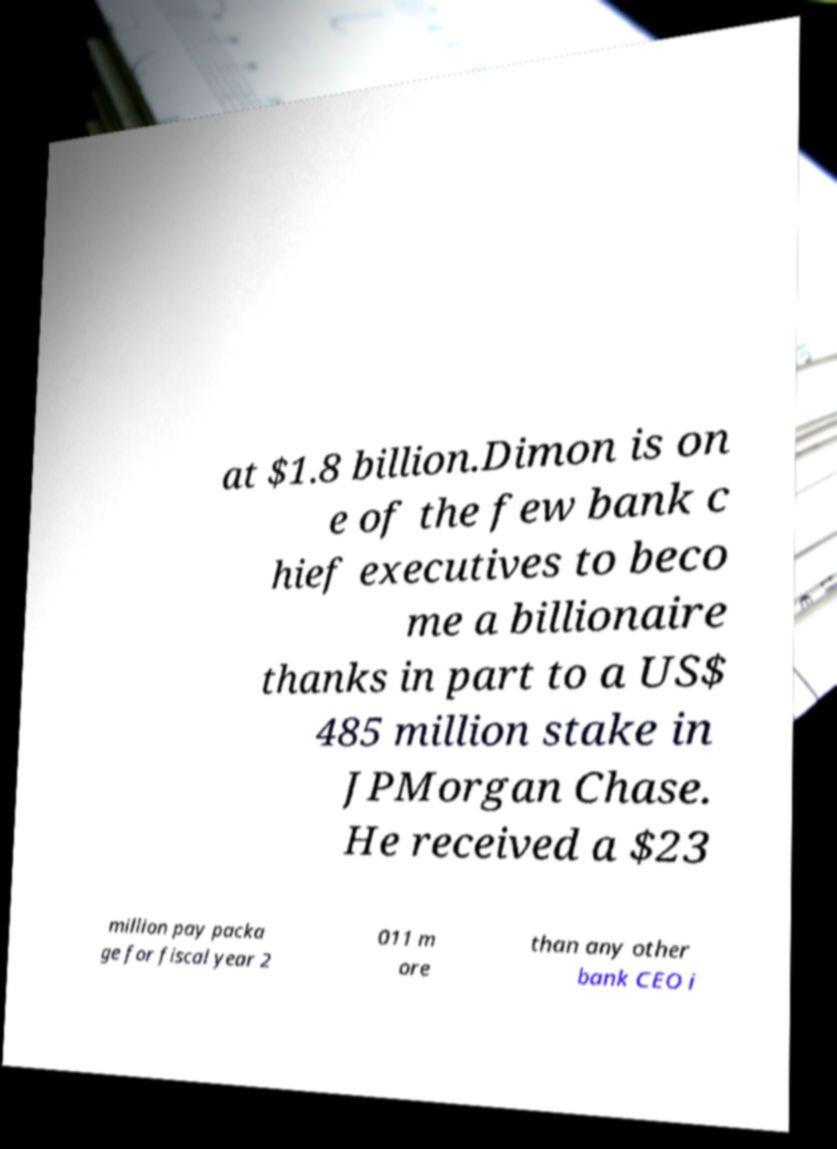For documentation purposes, I need the text within this image transcribed. Could you provide that? at $1.8 billion.Dimon is on e of the few bank c hief executives to beco me a billionaire thanks in part to a US$ 485 million stake in JPMorgan Chase. He received a $23 million pay packa ge for fiscal year 2 011 m ore than any other bank CEO i 